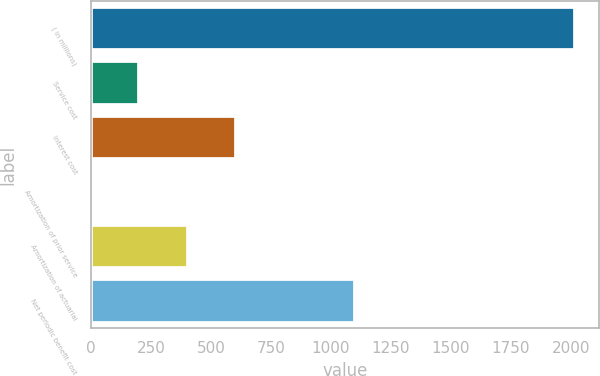Convert chart to OTSL. <chart><loc_0><loc_0><loc_500><loc_500><bar_chart><fcel>( in millions)<fcel>Service cost<fcel>Interest cost<fcel>Amortization of prior service<fcel>Amortization of actuarial<fcel>Net periodic benefit cost<nl><fcel>2016<fcel>202.5<fcel>605.5<fcel>1<fcel>404<fcel>1101<nl></chart> 